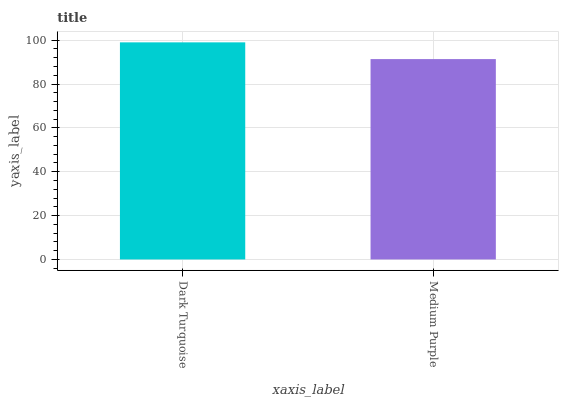Is Medium Purple the minimum?
Answer yes or no. Yes. Is Dark Turquoise the maximum?
Answer yes or no. Yes. Is Medium Purple the maximum?
Answer yes or no. No. Is Dark Turquoise greater than Medium Purple?
Answer yes or no. Yes. Is Medium Purple less than Dark Turquoise?
Answer yes or no. Yes. Is Medium Purple greater than Dark Turquoise?
Answer yes or no. No. Is Dark Turquoise less than Medium Purple?
Answer yes or no. No. Is Dark Turquoise the high median?
Answer yes or no. Yes. Is Medium Purple the low median?
Answer yes or no. Yes. Is Medium Purple the high median?
Answer yes or no. No. Is Dark Turquoise the low median?
Answer yes or no. No. 